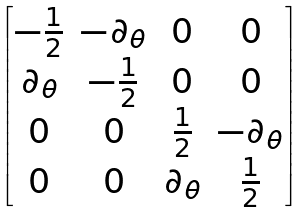<formula> <loc_0><loc_0><loc_500><loc_500>\begin{bmatrix} - \frac { 1 } { 2 } & - \partial _ { \theta } & 0 & 0 \\ \partial _ { \theta } & - \frac { 1 } { 2 } & 0 & 0 \\ 0 & 0 & \frac { 1 } { 2 } & - \partial _ { \theta } \\ 0 & 0 & \partial _ { \theta } & \frac { 1 } { 2 } \end{bmatrix}</formula> 